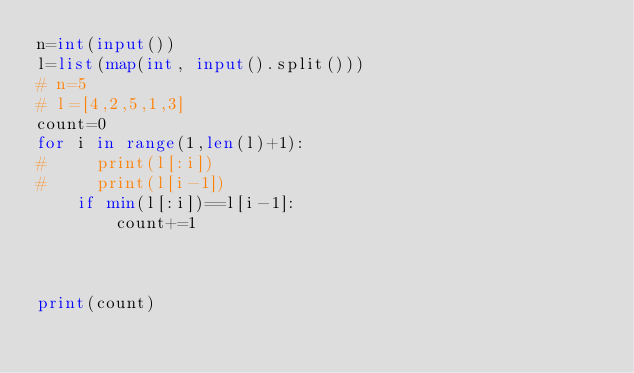<code> <loc_0><loc_0><loc_500><loc_500><_Python_>n=int(input())
l=list(map(int, input().split()))
# n=5
# l=[4,2,5,1,3]
count=0
for i in range(1,len(l)+1):
#     print(l[:i])
#     print(l[i-1])
    if min(l[:i])==l[i-1]:
        count+=1
    
    
    
print(count)</code> 